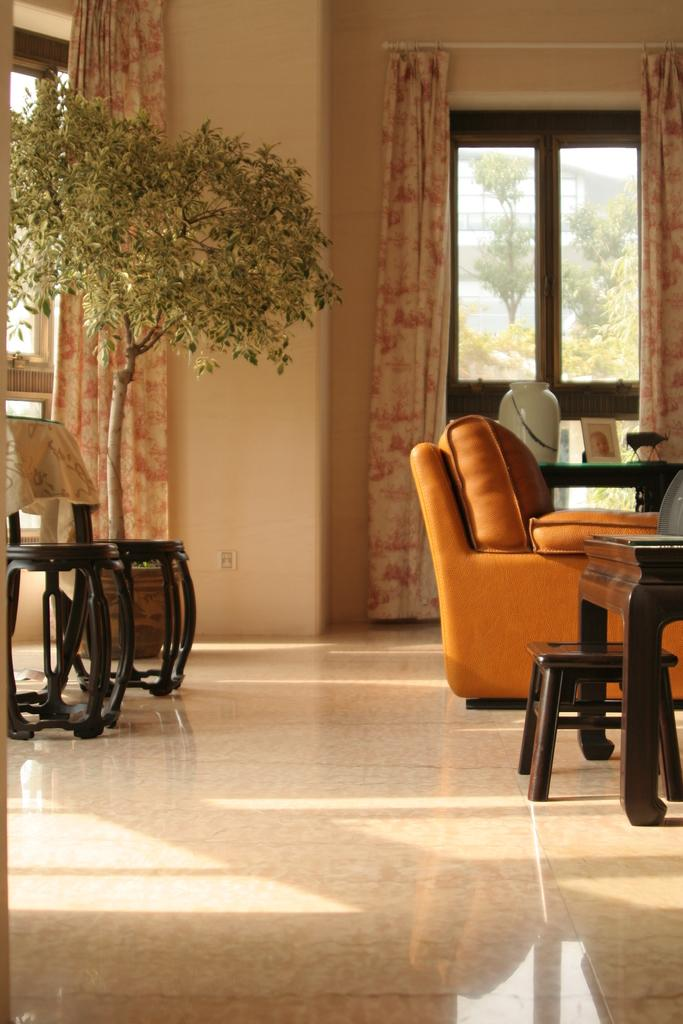What type of furniture is present in the image? There is a sofa, a table, and two stools in the image. What is on the table in the image? There are objects on the table in the image. How many stools are visible in the image? There are two stools in the image. What type of window treatment is present in the image? There is a curtain in the image. What is the background of the image? There is a wall and a window in the image, with trees visible through the window. What emotion is the ring expressing in the image? There is no ring present in the image, so it cannot express any emotion. 